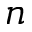<formula> <loc_0><loc_0><loc_500><loc_500>n</formula> 